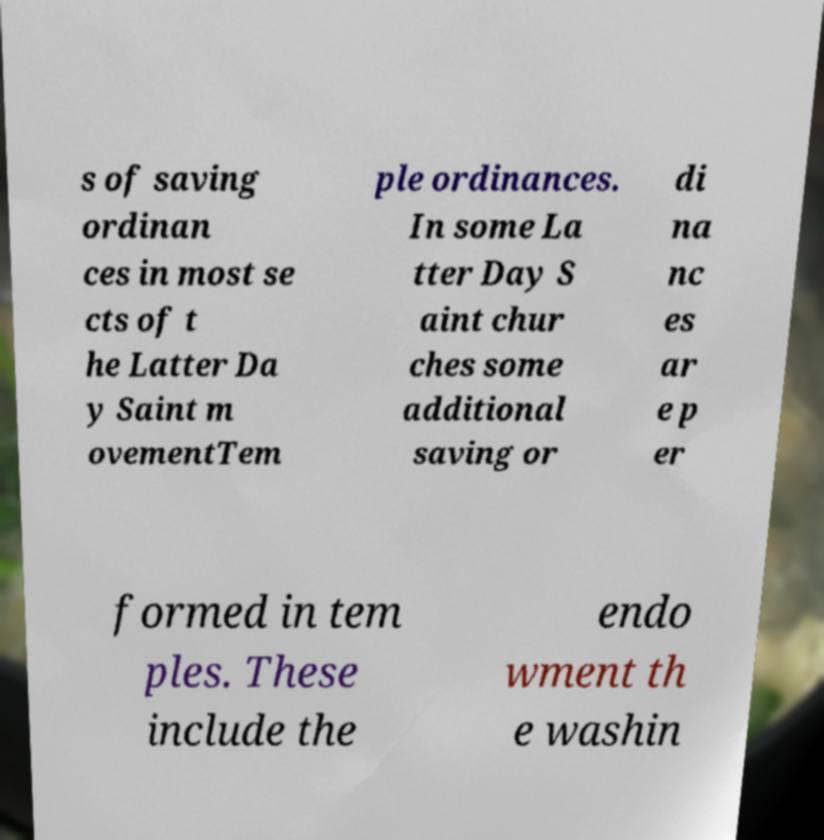Please identify and transcribe the text found in this image. s of saving ordinan ces in most se cts of t he Latter Da y Saint m ovementTem ple ordinances. In some La tter Day S aint chur ches some additional saving or di na nc es ar e p er formed in tem ples. These include the endo wment th e washin 